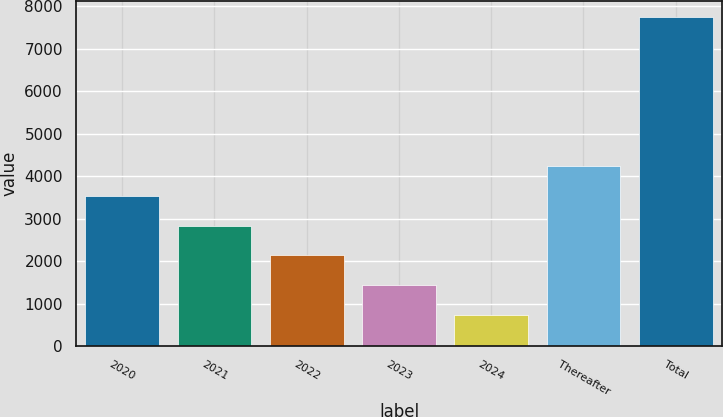<chart> <loc_0><loc_0><loc_500><loc_500><bar_chart><fcel>2020<fcel>2021<fcel>2022<fcel>2023<fcel>2024<fcel>Thereafter<fcel>Total<nl><fcel>3542.2<fcel>2840.9<fcel>2139.6<fcel>1438.3<fcel>737<fcel>4243.5<fcel>7750<nl></chart> 